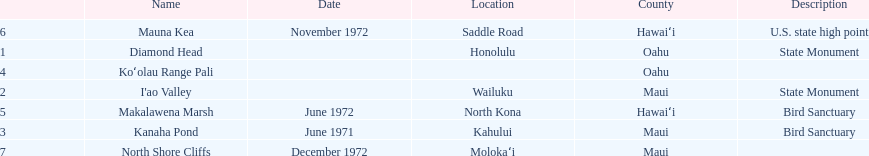What is the only name listed without a location? Koʻolau Range Pali. 